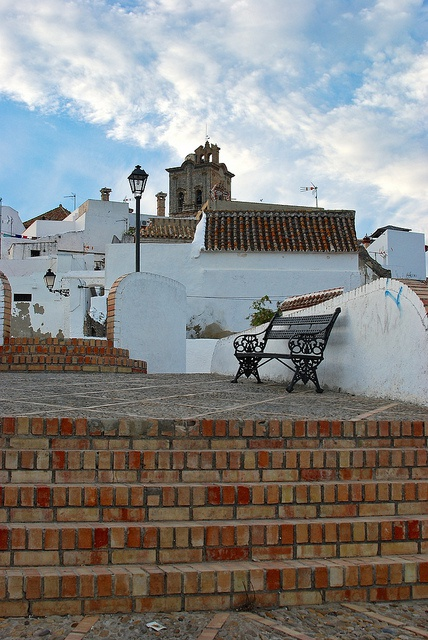Describe the objects in this image and their specific colors. I can see a bench in lightgray, black, gray, and darkgray tones in this image. 